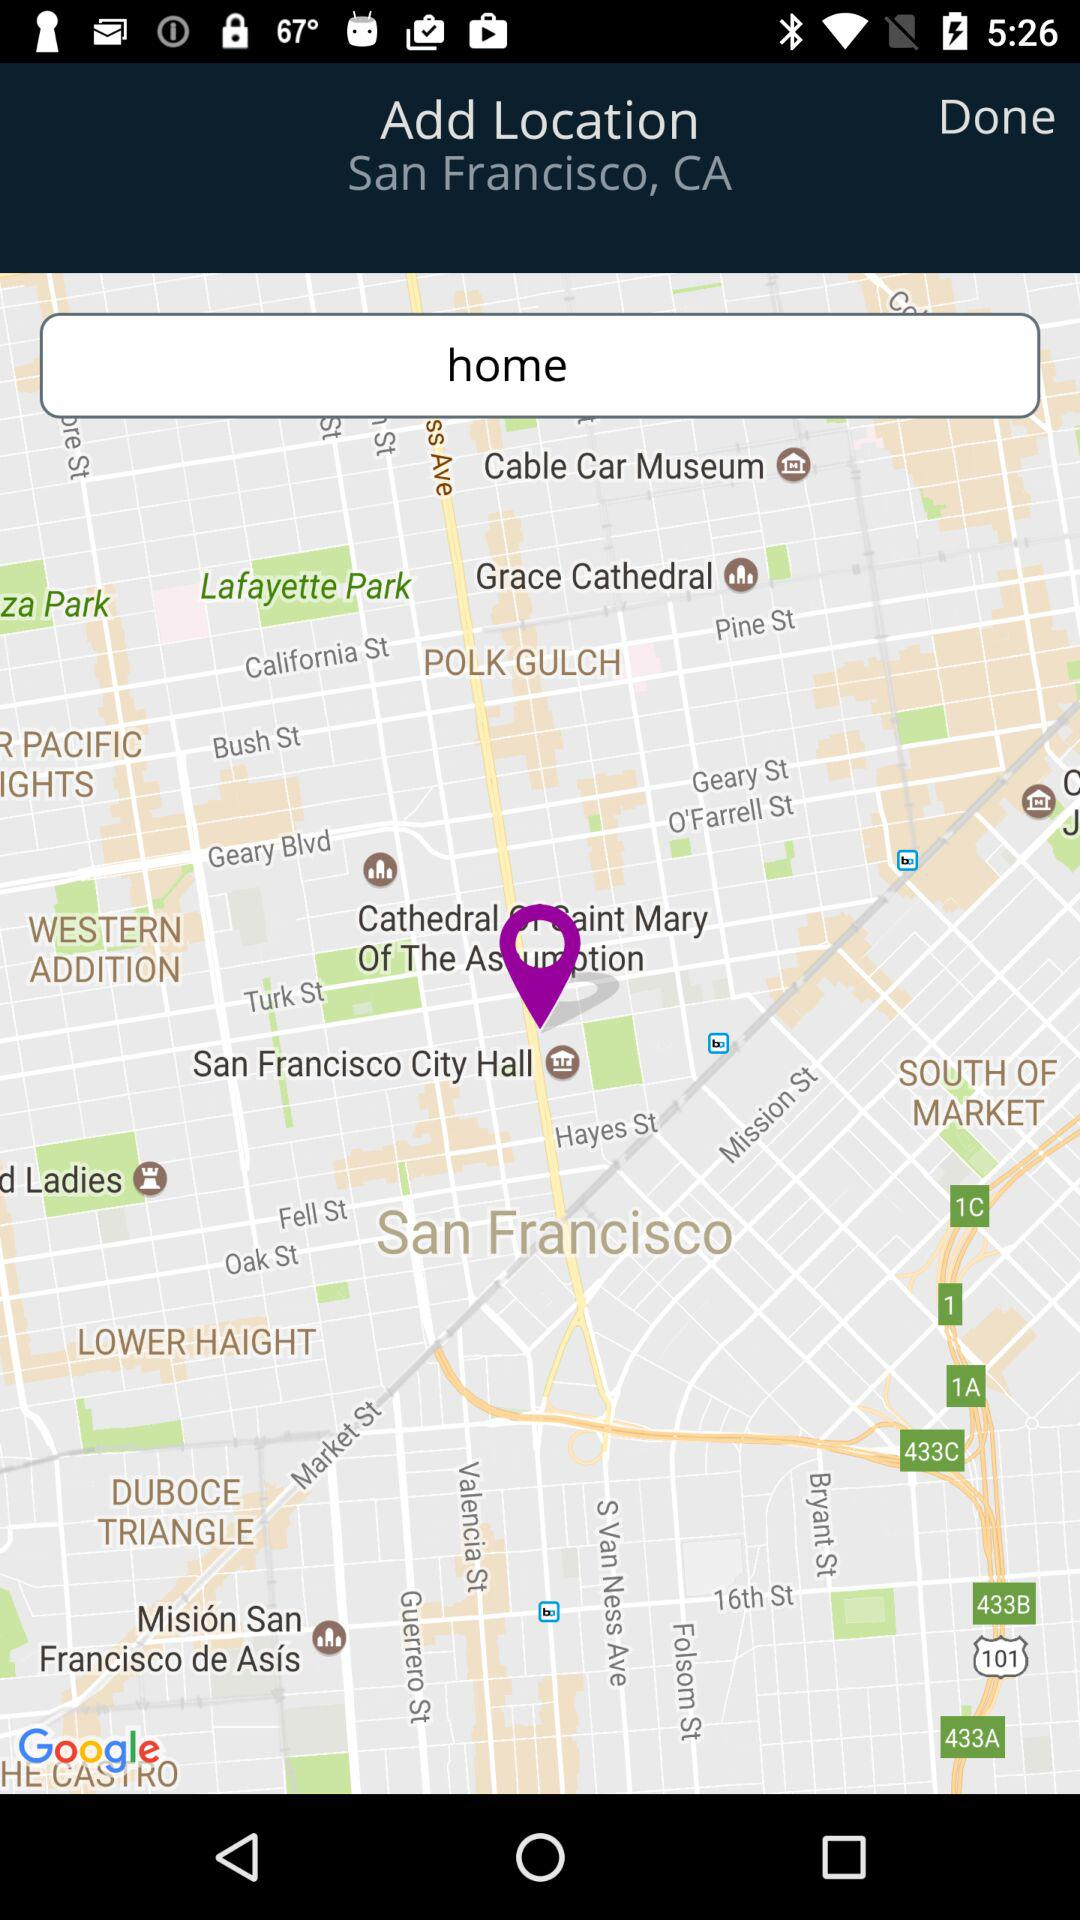What location is added? The added location is San Francisco, CA. 